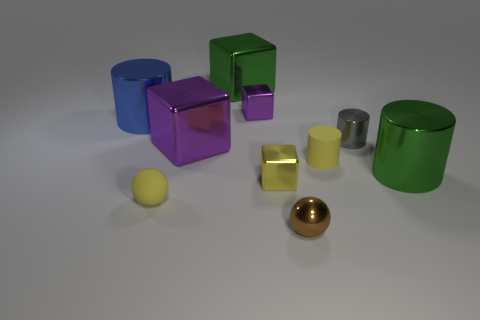The matte thing in front of the metallic object right of the tiny gray object on the right side of the tiny brown metallic thing is what shape?
Offer a very short reply. Sphere. What is the green thing that is to the left of the small shiny ball in front of the tiny gray cylinder made of?
Provide a succinct answer. Metal. There is a tiny brown thing that is the same material as the gray cylinder; what is its shape?
Ensure brevity in your answer.  Sphere. Are there any other things that have the same shape as the tiny brown metallic object?
Offer a terse response. Yes. There is a yellow shiny cube; how many large green metallic cylinders are behind it?
Make the answer very short. 1. Are there any large green shiny cylinders?
Give a very brief answer. Yes. What color is the small metal object that is on the right side of the small brown sphere in front of the big green shiny thing that is left of the green metallic cylinder?
Provide a short and direct response. Gray. There is a tiny brown shiny sphere to the left of the small metallic cylinder; are there any tiny brown shiny things in front of it?
Your response must be concise. No. There is a small matte object behind the matte sphere; is its color the same as the small metal block that is behind the small gray shiny object?
Make the answer very short. No. What number of yellow objects are the same size as the rubber cylinder?
Your answer should be very brief. 2. 